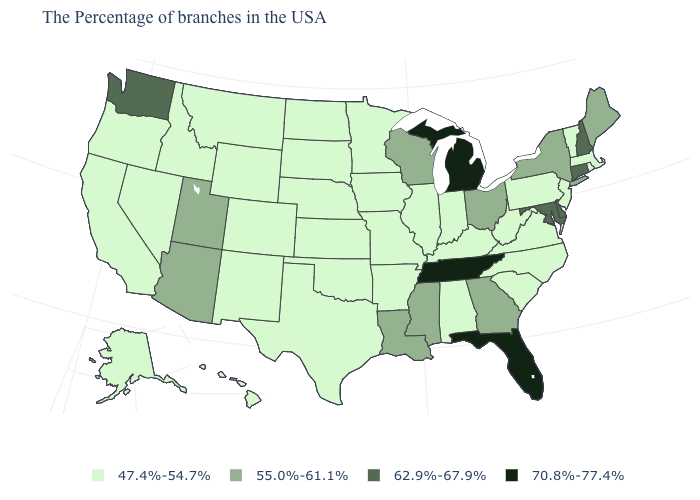What is the value of Pennsylvania?
Concise answer only. 47.4%-54.7%. What is the value of Arkansas?
Be succinct. 47.4%-54.7%. Among the states that border Utah , which have the highest value?
Short answer required. Arizona. Does the first symbol in the legend represent the smallest category?
Answer briefly. Yes. Among the states that border South Carolina , which have the highest value?
Concise answer only. Georgia. Among the states that border Arizona , does New Mexico have the lowest value?
Short answer required. Yes. Does New York have the lowest value in the Northeast?
Short answer required. No. Name the states that have a value in the range 62.9%-67.9%?
Keep it brief. New Hampshire, Connecticut, Delaware, Maryland, Washington. Which states have the highest value in the USA?
Write a very short answer. Florida, Michigan, Tennessee. What is the value of Oregon?
Answer briefly. 47.4%-54.7%. Which states have the lowest value in the Northeast?
Quick response, please. Massachusetts, Rhode Island, Vermont, New Jersey, Pennsylvania. What is the lowest value in states that border Montana?
Answer briefly. 47.4%-54.7%. What is the highest value in the USA?
Give a very brief answer. 70.8%-77.4%. Which states have the lowest value in the Northeast?
Answer briefly. Massachusetts, Rhode Island, Vermont, New Jersey, Pennsylvania. What is the value of Montana?
Write a very short answer. 47.4%-54.7%. 